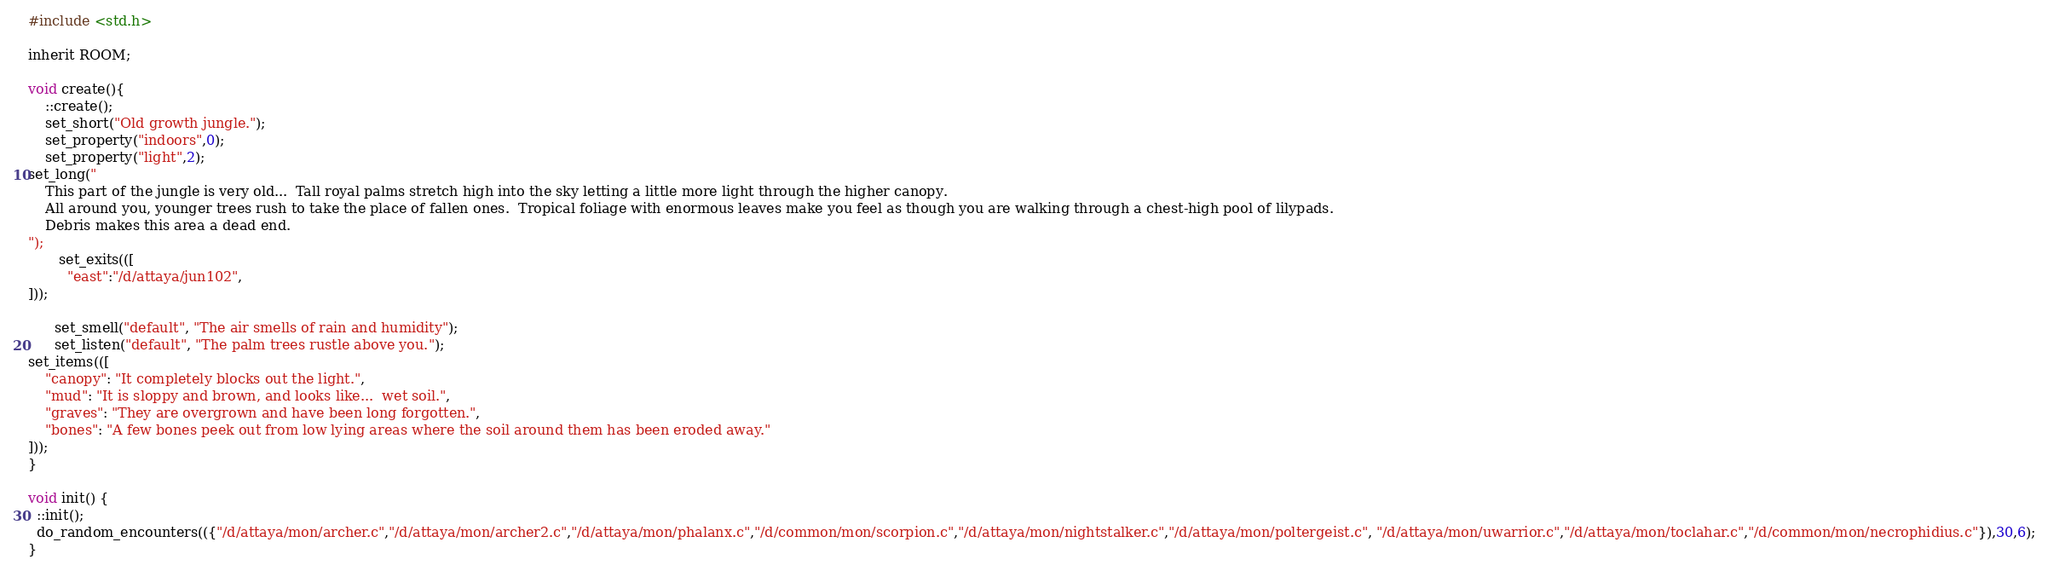<code> <loc_0><loc_0><loc_500><loc_500><_C_>
#include <std.h>

inherit ROOM;

void create(){
	::create();
	set_short("Old growth jungle.");
	set_property("indoors",0);
	set_property("light",2);
set_long("
    This part of the jungle is very old...  Tall royal palms stretch high into the sky letting a little more light through the higher canopy.
    All around you, younger trees rush to take the place of fallen ones.  Tropical foliage with enormous leaves make you feel as though you are walking through a chest-high pool of lilypads.
    Debris makes this area a dead end.
");
       set_exits(([
         "east":"/d/attaya/jun102",
]));
	
      set_smell("default", "The air smells of rain and humidity");
      set_listen("default", "The palm trees rustle above you.");
set_items(([
    "canopy": "It completely blocks out the light.",
    "mud": "It is sloppy and brown, and looks like...  wet soil.",
    "graves": "They are overgrown and have been long forgotten.",
    "bones": "A few bones peek out from low lying areas where the soil around them has been eroded away."
]));
}

void init() {
  ::init();
  do_random_encounters(({"/d/attaya/mon/archer.c","/d/attaya/mon/archer2.c","/d/attaya/mon/phalanx.c","/d/common/mon/scorpion.c","/d/attaya/mon/nightstalker.c","/d/attaya/mon/poltergeist.c", "/d/attaya/mon/uwarrior.c","/d/attaya/mon/toclahar.c","/d/common/mon/necrophidius.c"}),30,6);
}
</code> 